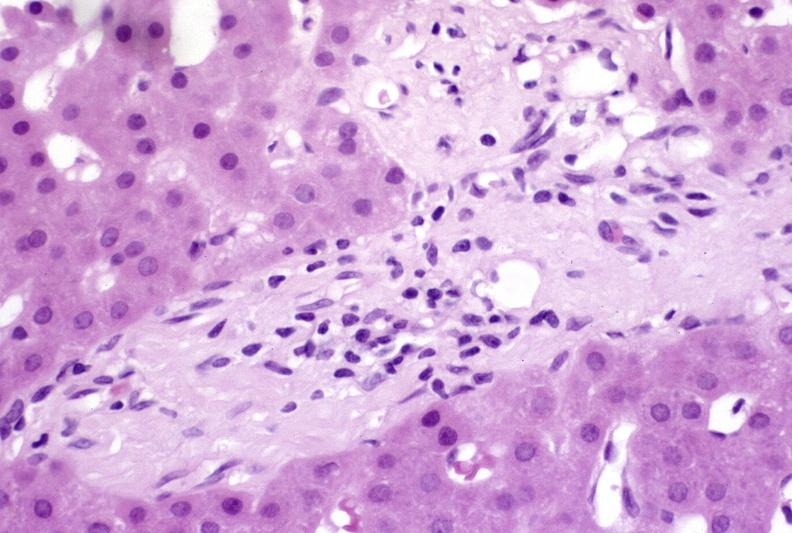what does this image show?
Answer the question using a single word or phrase. Ductopenia 